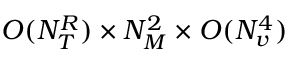Convert formula to latex. <formula><loc_0><loc_0><loc_500><loc_500>O ( N _ { T } ^ { R } ) \times N _ { M } ^ { 2 } \times O ( N _ { v } ^ { 4 } )</formula> 